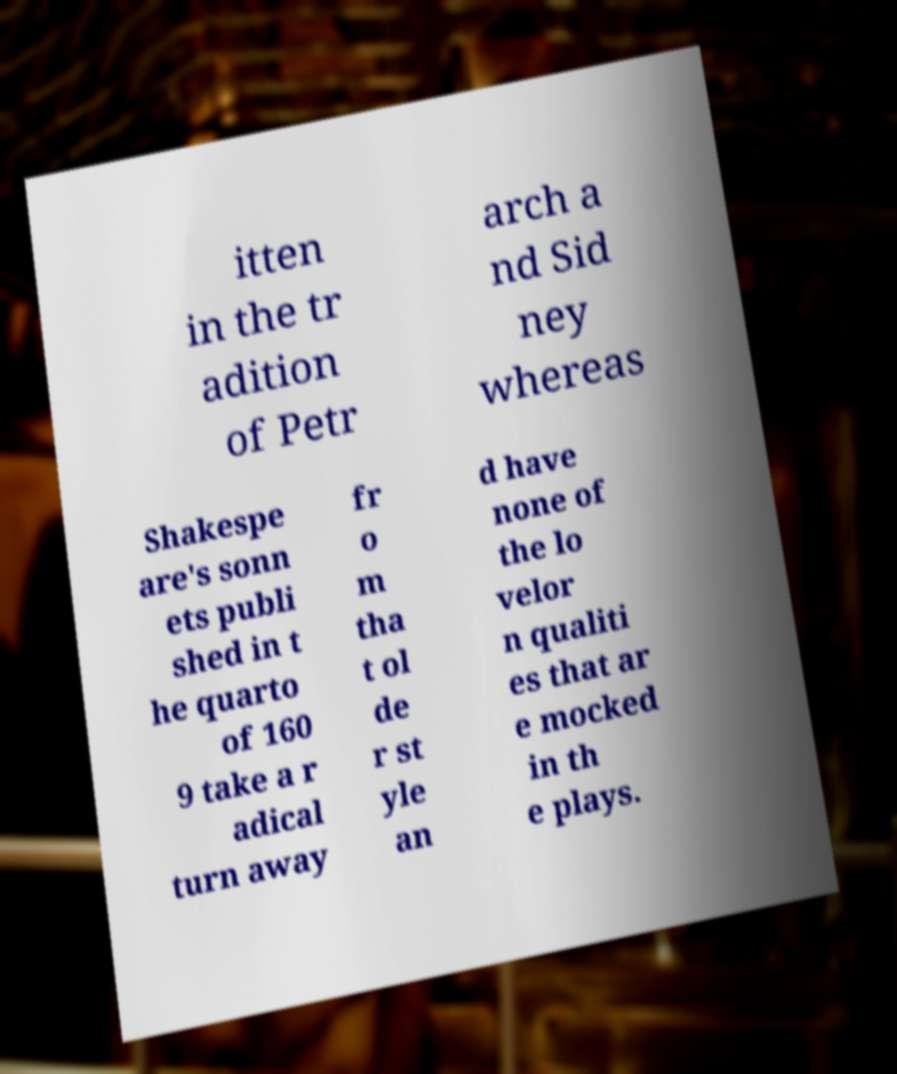Please read and relay the text visible in this image. What does it say? itten in the tr adition of Petr arch a nd Sid ney whereas Shakespe are's sonn ets publi shed in t he quarto of 160 9 take a r adical turn away fr o m tha t ol de r st yle an d have none of the lo velor n qualiti es that ar e mocked in th e plays. 